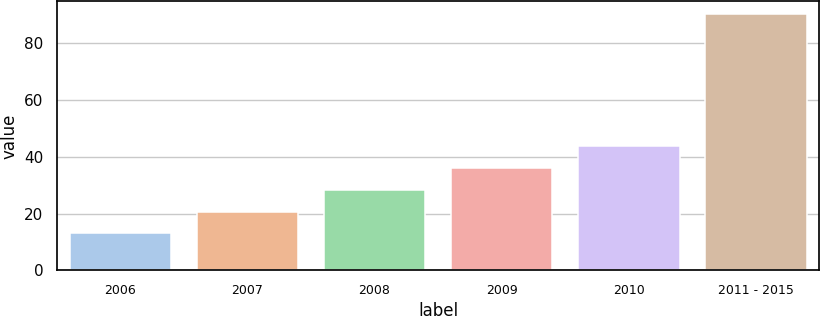Convert chart. <chart><loc_0><loc_0><loc_500><loc_500><bar_chart><fcel>2006<fcel>2007<fcel>2008<fcel>2009<fcel>2010<fcel>2011 - 2015<nl><fcel>13<fcel>20.7<fcel>28.4<fcel>36.1<fcel>43.8<fcel>90<nl></chart> 